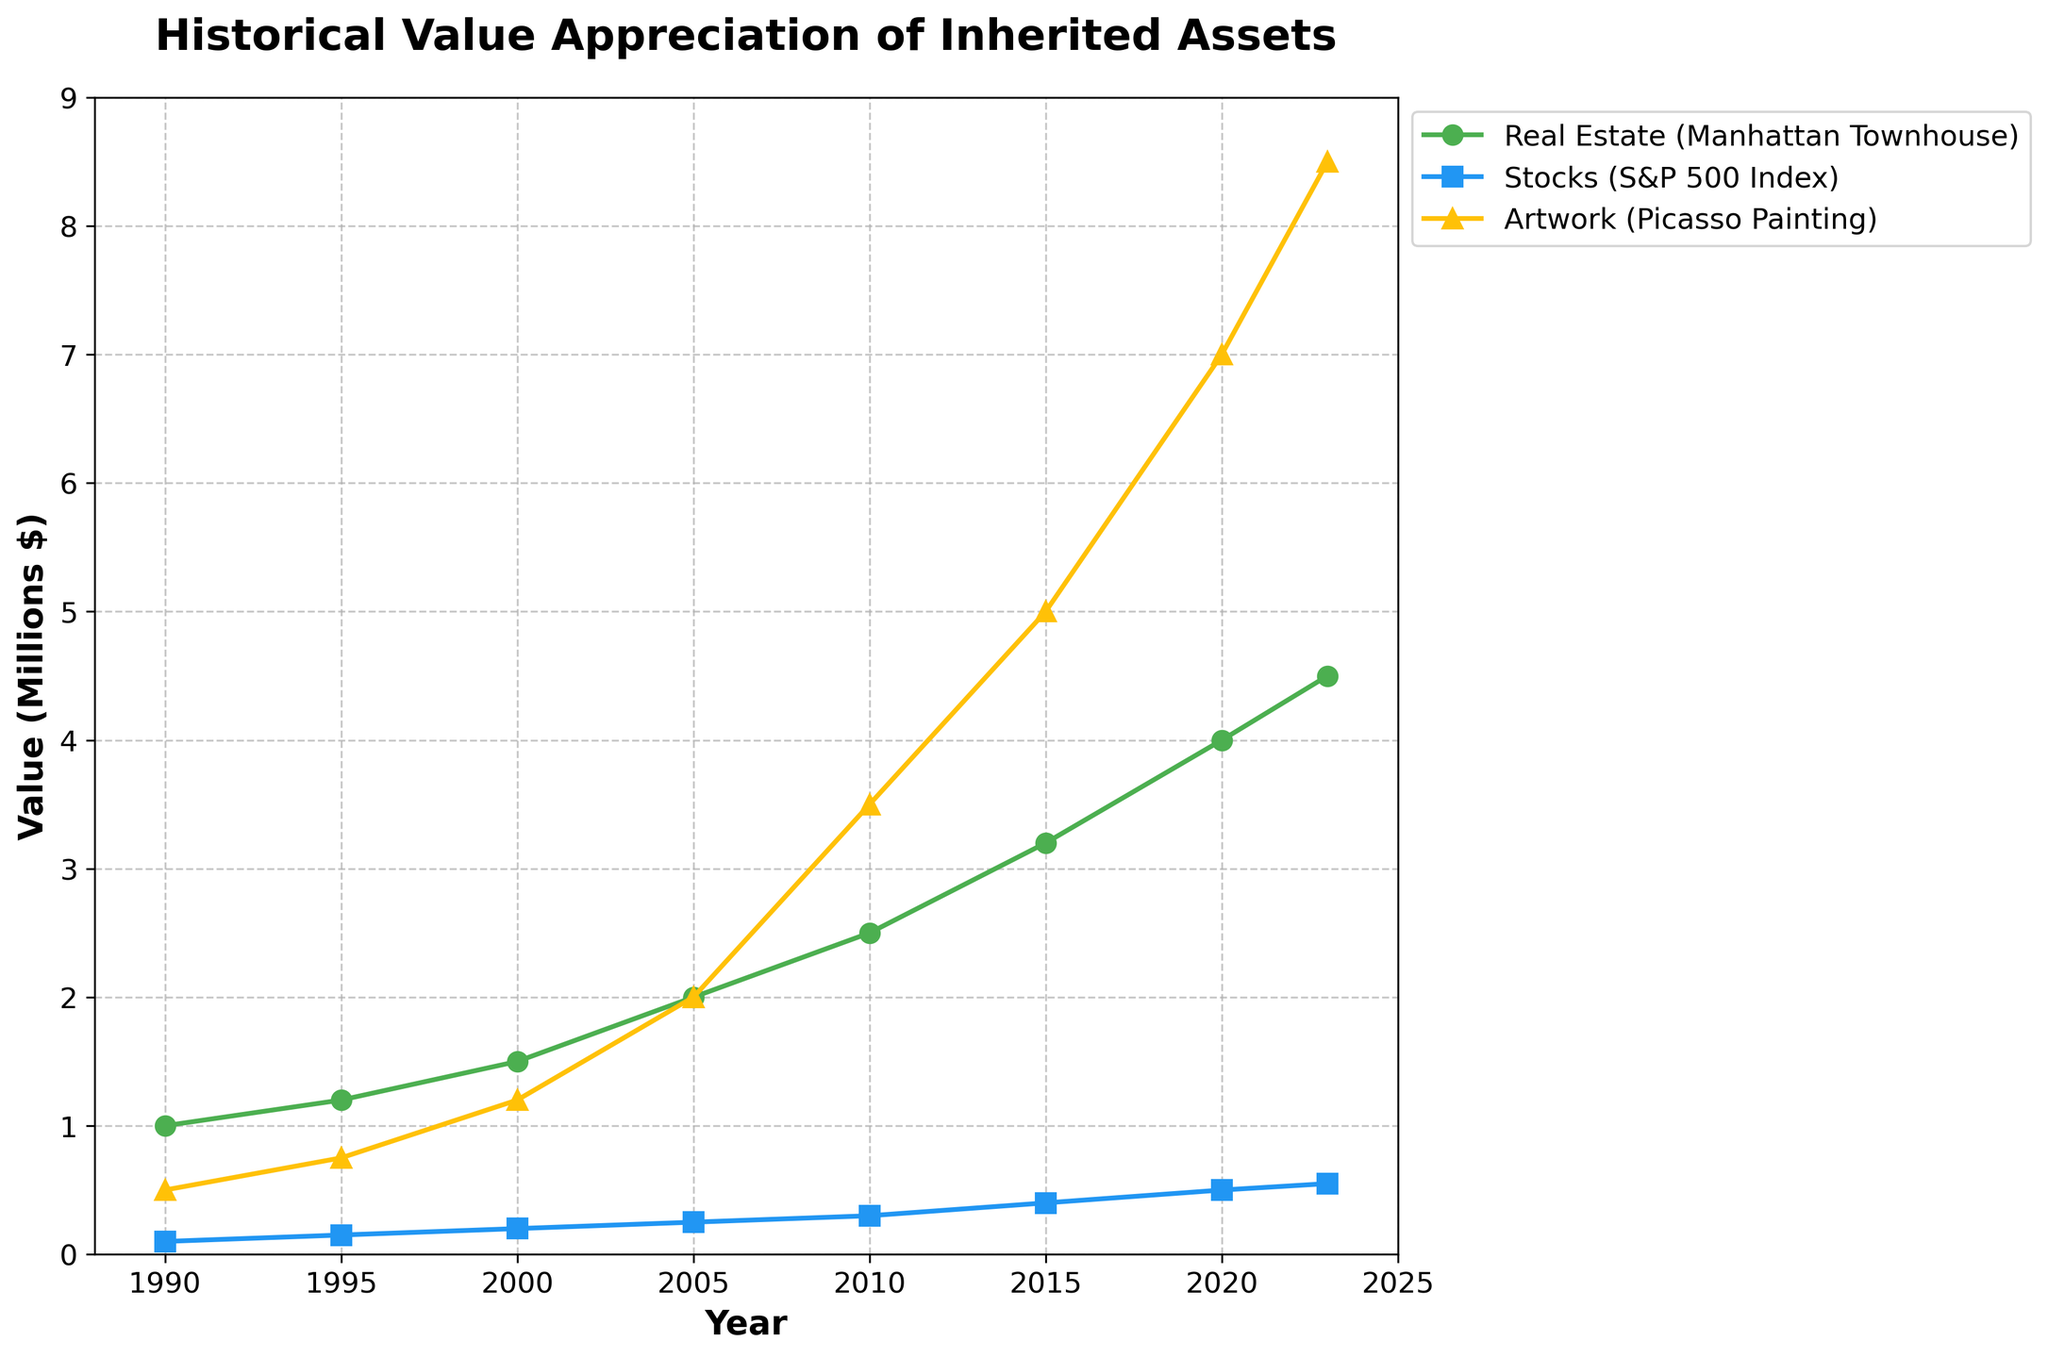What's the value of the Manhattan Townhouse in 2023? The value of the Manhattan Townhouse in 2023 can be identified by looking at the 2023 data point on the line plot associated with 'Real Estate (Manhattan Townhouse)'. The value is 4.5 million dollars.
Answer: 4.5 million Which asset had the highest value in 2020? By comparing the 2020 data points of all three assets on the line plot, the highest value in 2020 belongs to the 'Artwork (Picasso Painting)' line, which reaches 7 million dollars.
Answer: Artwork (Picasso Painting) Has the value of the S&P 500 index ever surpassed the value of the Manhattan Townhouse? Observing the line plot for all years, the value of 'Stocks (S&P 500 Index)' never surpasses the value of 'Real Estate (Manhattan Townhouse)'.
Answer: No What is the percentage increase in value of the Picasso Painting from 2000 to 2020? First, find the values at 2000 and 2020: 1.2 million and 7 million respectively. Calculate the increase: 7 million - 1.2 million = 5.8 million. Then, find the percentage increase: (5.8 million / 1.2 million) * 100%.
Answer: 483.33% Which asset showed the most consistent growth over the period 1990 to 2023? By analyzing the slopes of the three lines, 'Real Estate (Manhattan Townhouse)' shows a consistent and linear increase without sharp dips or anomalies, indicating the most consistent growth.
Answer: Real Estate (Manhattan Townhouse) What is the combined value of all three assets in 2015? Look at the values in 2015: Real Estate (3.2 million), Stocks (0.4 million), and Artwork (5 million). Add them together: 3.2 + 0.4 + 5 = 8.6 million dollars.
Answer: 8.6 million How does the growth rate of stocks from 1990 to 1995 compare to the growth rate of artwork in the same period? The value of stocks grew from 100,000 to 150,000, a 50% increase. The value of artwork grew from 500,000 to 750,000, also a 50% increase. Therefore, the growth rates are the same.
Answer: Equal What trend is observed in the value of 'Artwork (Picasso Painting)' from 2005 to 2010? The value of 'Artwork (Picasso Painting)' increases significantly from 2 million dollars in 2005 to 3.5 million dollars in 2010, indicating a rapid appreciation.
Answer: Rapid appreciation Which year saw the steepest increase in the value of the Manhattan Townhouse? By observing the slope of the lines, the steepest increase in the value of 'Real Estate (Manhattan Townhouse)' occurred between 2000 and 2005.
Answer: 2000 to 2005 